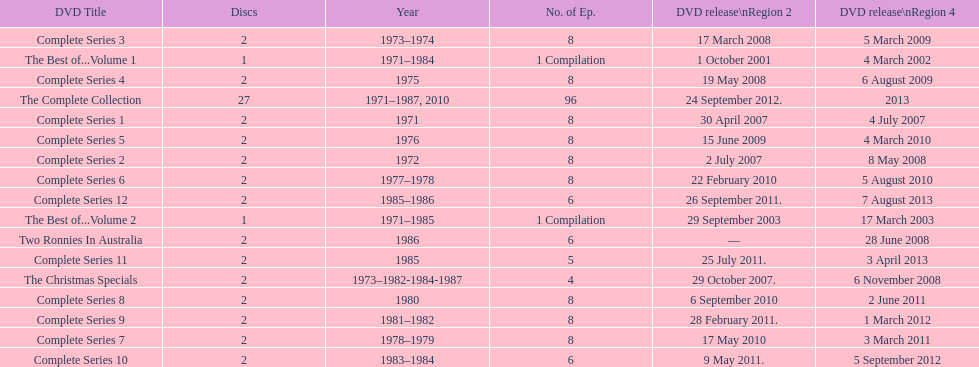What is the sum of all discs listed in the table? 57. 